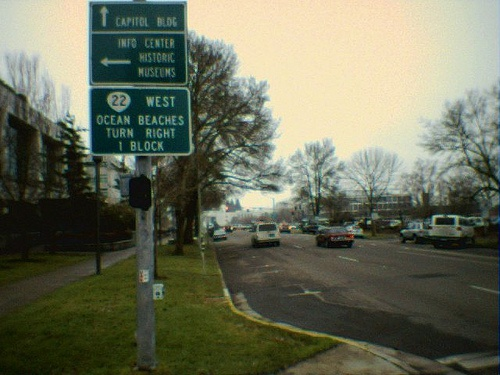Describe the objects in this image and their specific colors. I can see truck in lightgray, black, gray, and darkgreen tones, car in lightgray, black, gray, and maroon tones, car in lightgray, black, and gray tones, truck in lightgray, black, gray, teal, and darkgreen tones, and car in lightgray, black, teal, and darkgreen tones in this image. 